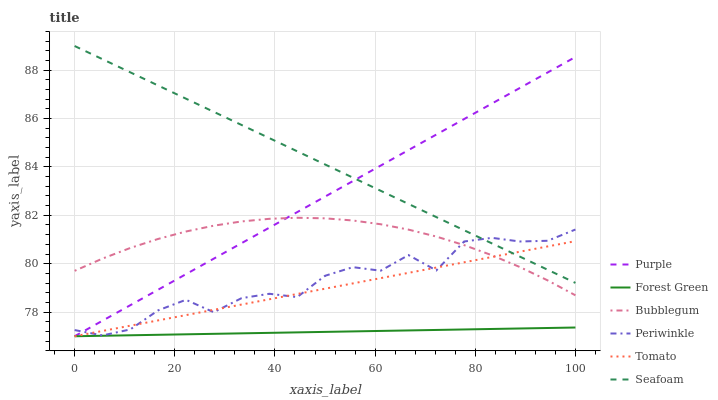Does Forest Green have the minimum area under the curve?
Answer yes or no. Yes. Does Seafoam have the maximum area under the curve?
Answer yes or no. Yes. Does Purple have the minimum area under the curve?
Answer yes or no. No. Does Purple have the maximum area under the curve?
Answer yes or no. No. Is Forest Green the smoothest?
Answer yes or no. Yes. Is Periwinkle the roughest?
Answer yes or no. Yes. Is Purple the smoothest?
Answer yes or no. No. Is Purple the roughest?
Answer yes or no. No. Does Tomato have the lowest value?
Answer yes or no. Yes. Does Seafoam have the lowest value?
Answer yes or no. No. Does Seafoam have the highest value?
Answer yes or no. Yes. Does Purple have the highest value?
Answer yes or no. No. Is Forest Green less than Seafoam?
Answer yes or no. Yes. Is Periwinkle greater than Forest Green?
Answer yes or no. Yes. Does Bubblegum intersect Periwinkle?
Answer yes or no. Yes. Is Bubblegum less than Periwinkle?
Answer yes or no. No. Is Bubblegum greater than Periwinkle?
Answer yes or no. No. Does Forest Green intersect Seafoam?
Answer yes or no. No. 